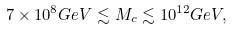<formula> <loc_0><loc_0><loc_500><loc_500>7 \times 1 0 ^ { 8 } G e V \lesssim M _ { c } \lesssim 1 0 ^ { 1 2 } G e V ,</formula> 